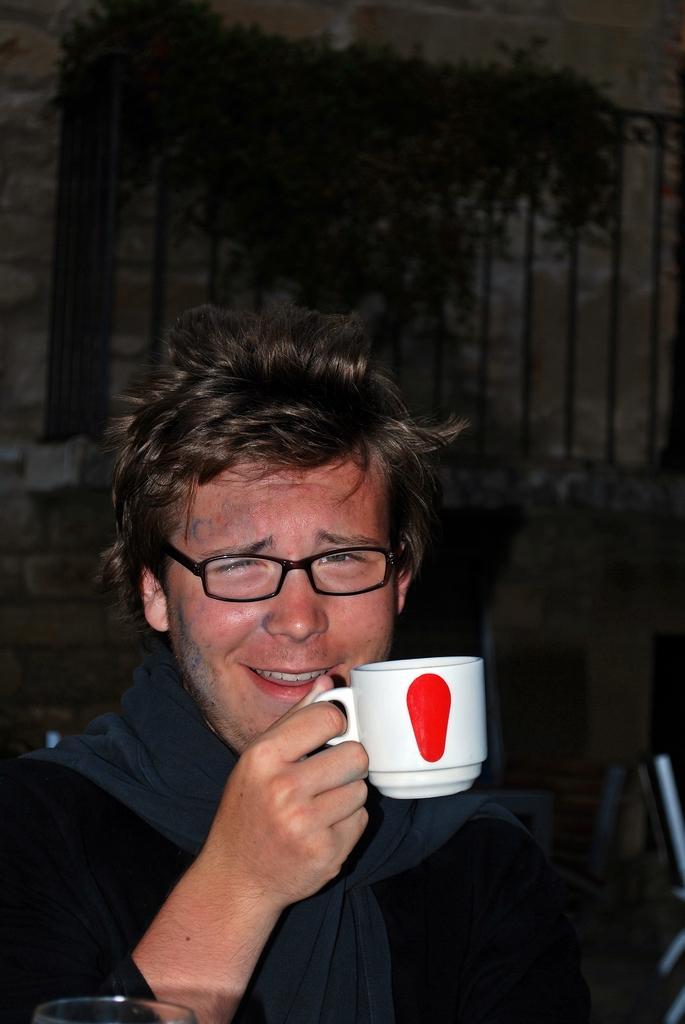Could you give a brief overview of what you see in this image? In this image there is one man who is smiling and he is holding a cup. On the background there is a wall and some plants are there. 